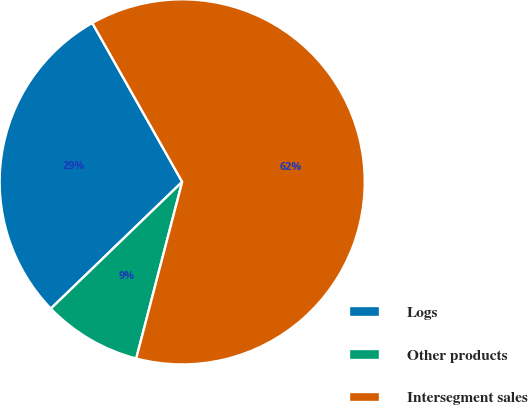<chart> <loc_0><loc_0><loc_500><loc_500><pie_chart><fcel>Logs<fcel>Other products<fcel>Intersegment sales<nl><fcel>29.02%<fcel>8.73%<fcel>62.24%<nl></chart> 